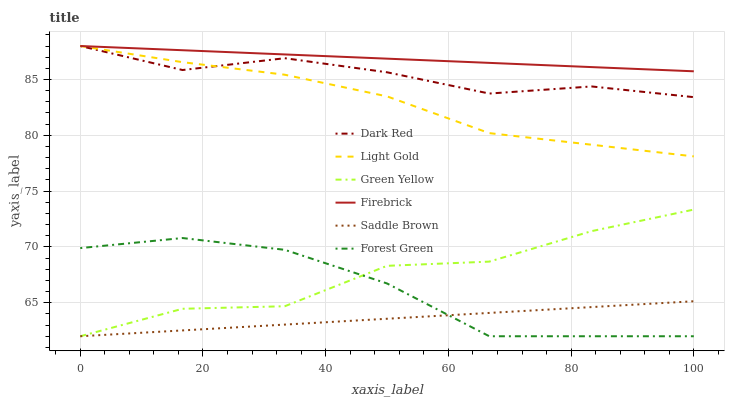Does Saddle Brown have the minimum area under the curve?
Answer yes or no. Yes. Does Firebrick have the maximum area under the curve?
Answer yes or no. Yes. Does Forest Green have the minimum area under the curve?
Answer yes or no. No. Does Forest Green have the maximum area under the curve?
Answer yes or no. No. Is Saddle Brown the smoothest?
Answer yes or no. Yes. Is Green Yellow the roughest?
Answer yes or no. Yes. Is Firebrick the smoothest?
Answer yes or no. No. Is Firebrick the roughest?
Answer yes or no. No. Does Forest Green have the lowest value?
Answer yes or no. Yes. Does Firebrick have the lowest value?
Answer yes or no. No. Does Light Gold have the highest value?
Answer yes or no. Yes. Does Forest Green have the highest value?
Answer yes or no. No. Is Forest Green less than Firebrick?
Answer yes or no. Yes. Is Firebrick greater than Saddle Brown?
Answer yes or no. Yes. Does Forest Green intersect Saddle Brown?
Answer yes or no. Yes. Is Forest Green less than Saddle Brown?
Answer yes or no. No. Is Forest Green greater than Saddle Brown?
Answer yes or no. No. Does Forest Green intersect Firebrick?
Answer yes or no. No. 